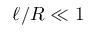<formula> <loc_0><loc_0><loc_500><loc_500>\ell / R \ll 1</formula> 